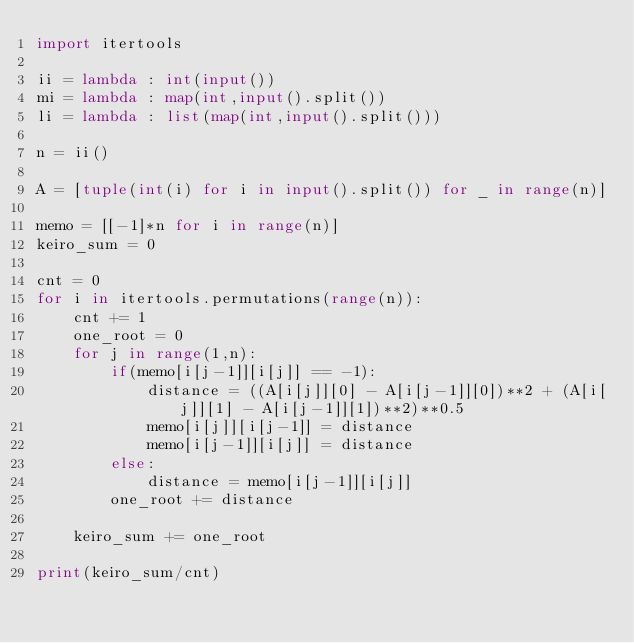<code> <loc_0><loc_0><loc_500><loc_500><_Python_>import itertools

ii = lambda : int(input())
mi = lambda : map(int,input().split())
li = lambda : list(map(int,input().split()))

n = ii()

A = [tuple(int(i) for i in input().split()) for _ in range(n)]

memo = [[-1]*n for i in range(n)]
keiro_sum = 0

cnt = 0
for i in itertools.permutations(range(n)):
    cnt += 1
    one_root = 0
    for j in range(1,n):
        if(memo[i[j-1]][i[j]] == -1):
            distance = ((A[i[j]][0] - A[i[j-1]][0])**2 + (A[i[j]][1] - A[i[j-1]][1])**2)**0.5
            memo[i[j]][i[j-1]] = distance
            memo[i[j-1]][i[j]] = distance
        else:
            distance = memo[i[j-1]][i[j]]
        one_root += distance

    keiro_sum += one_root

print(keiro_sum/cnt)

        
</code> 